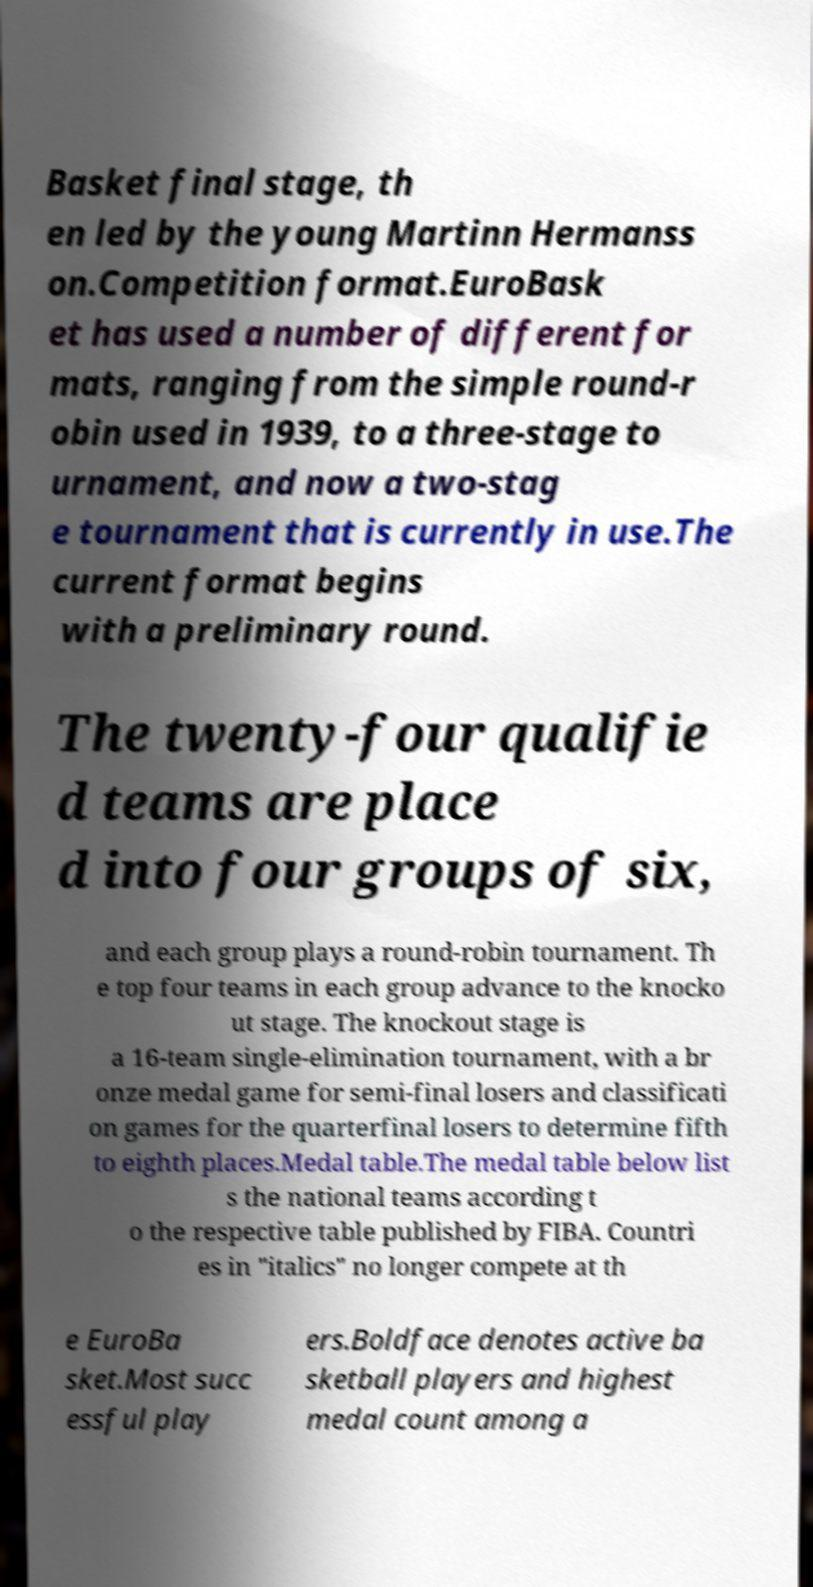For documentation purposes, I need the text within this image transcribed. Could you provide that? Basket final stage, th en led by the young Martinn Hermanss on.Competition format.EuroBask et has used a number of different for mats, ranging from the simple round-r obin used in 1939, to a three-stage to urnament, and now a two-stag e tournament that is currently in use.The current format begins with a preliminary round. The twenty-four qualifie d teams are place d into four groups of six, and each group plays a round-robin tournament. Th e top four teams in each group advance to the knocko ut stage. The knockout stage is a 16-team single-elimination tournament, with a br onze medal game for semi-final losers and classificati on games for the quarterfinal losers to determine fifth to eighth places.Medal table.The medal table below list s the national teams according t o the respective table published by FIBA. Countri es in "italics" no longer compete at th e EuroBa sket.Most succ essful play ers.Boldface denotes active ba sketball players and highest medal count among a 